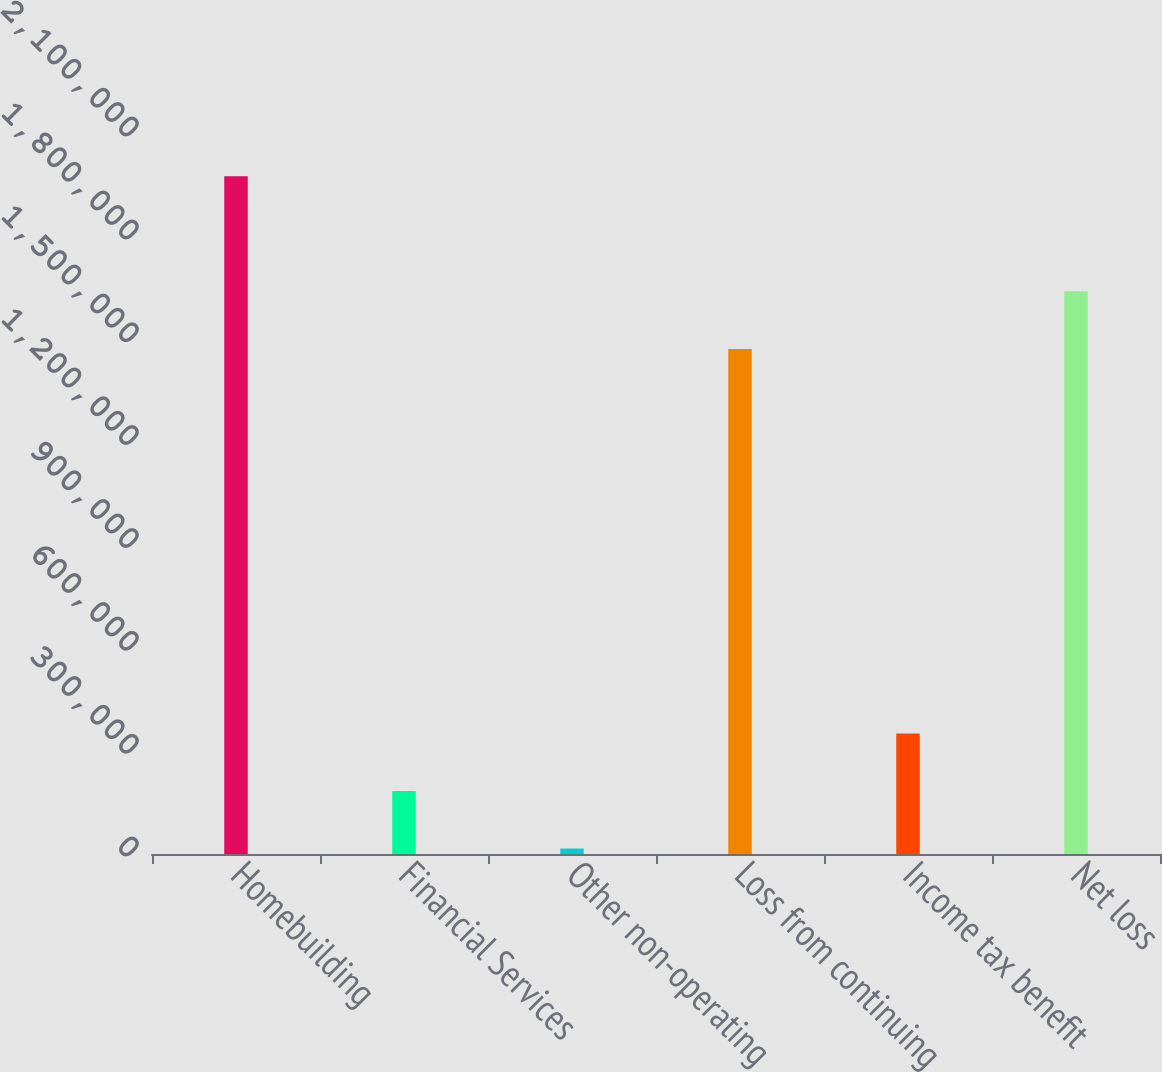Convert chart. <chart><loc_0><loc_0><loc_500><loc_500><bar_chart><fcel>Homebuilding<fcel>Financial Services<fcel>Other non-operating<fcel>Loss from continuing<fcel>Income tax benefit<fcel>Net loss<nl><fcel>1.97675e+06<fcel>183811<fcel>15933<fcel>1.47311e+06<fcel>351689<fcel>1.64099e+06<nl></chart> 